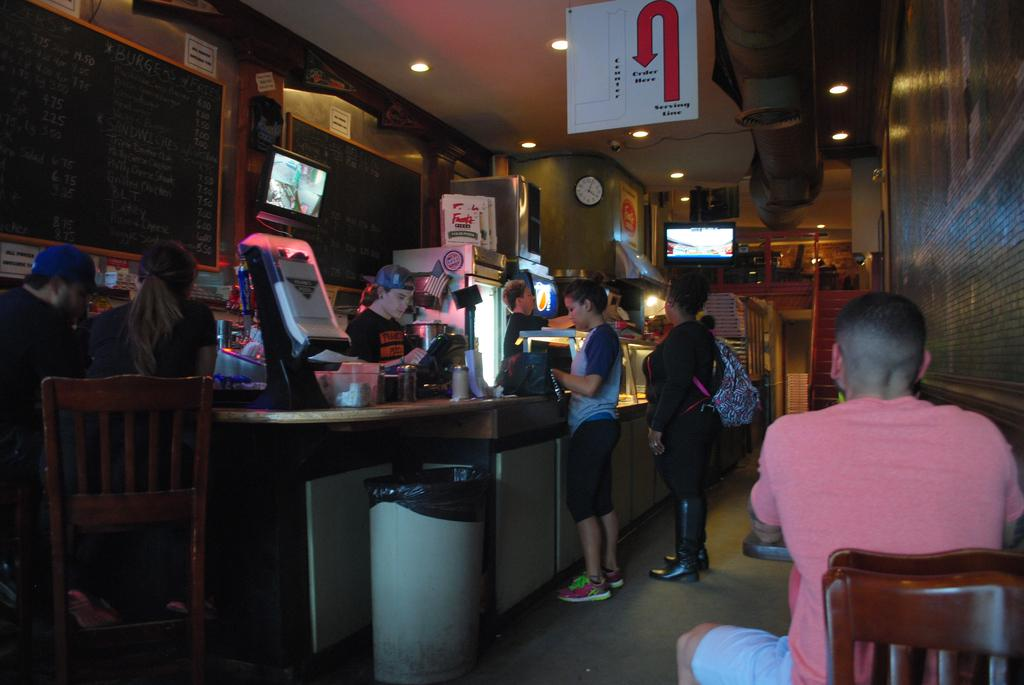What type of structure is present in the image? There is a wall in the image. What object can be used to tell time? There is a clock in the image. What device is present in the image for displaying information or visuals? There is a screen in the image. What surface is available for writing or displaying information? There is a board in the image. What are the people in the image doing? There are people standing and sitting on chairs in the image. Can you see any fangs in the image? There are no fangs present in the image. What type of error is being displayed on the screen in the image? There is no error displayed on the screen in the image. 